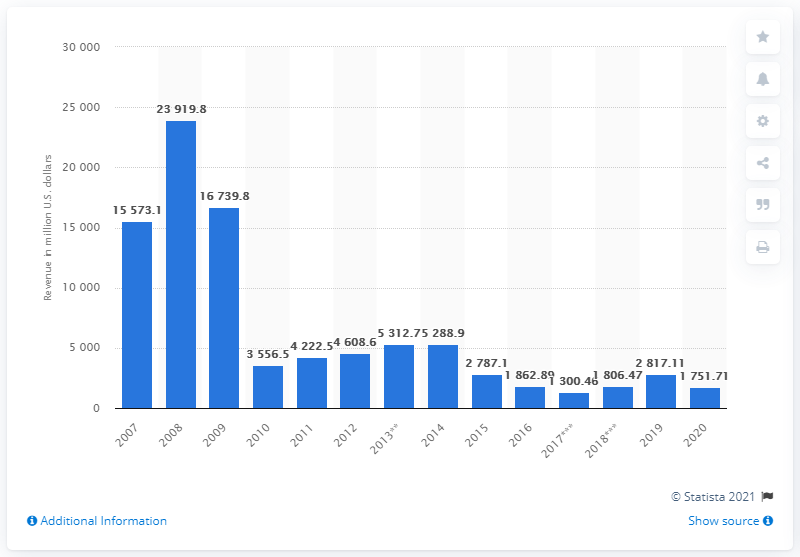Draw attention to some important aspects in this diagram. In 2020, Murphy Oil Corporation's revenue was approximately $1806.47 million. In the year prior, Murphy Oil Corporation's revenue was 2817.11. 